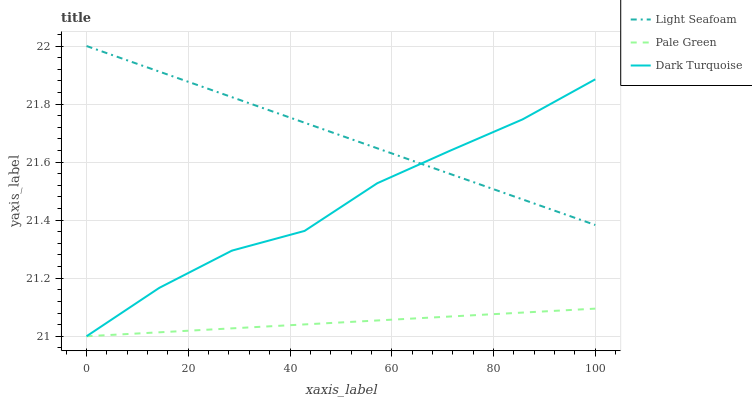Does Pale Green have the minimum area under the curve?
Answer yes or no. Yes. Does Light Seafoam have the maximum area under the curve?
Answer yes or no. Yes. Does Dark Turquoise have the minimum area under the curve?
Answer yes or no. No. Does Dark Turquoise have the maximum area under the curve?
Answer yes or no. No. Is Pale Green the smoothest?
Answer yes or no. Yes. Is Dark Turquoise the roughest?
Answer yes or no. Yes. Is Light Seafoam the smoothest?
Answer yes or no. No. Is Light Seafoam the roughest?
Answer yes or no. No. Does Light Seafoam have the lowest value?
Answer yes or no. No. Does Dark Turquoise have the highest value?
Answer yes or no. No. Is Pale Green less than Light Seafoam?
Answer yes or no. Yes. Is Light Seafoam greater than Pale Green?
Answer yes or no. Yes. Does Pale Green intersect Light Seafoam?
Answer yes or no. No. 